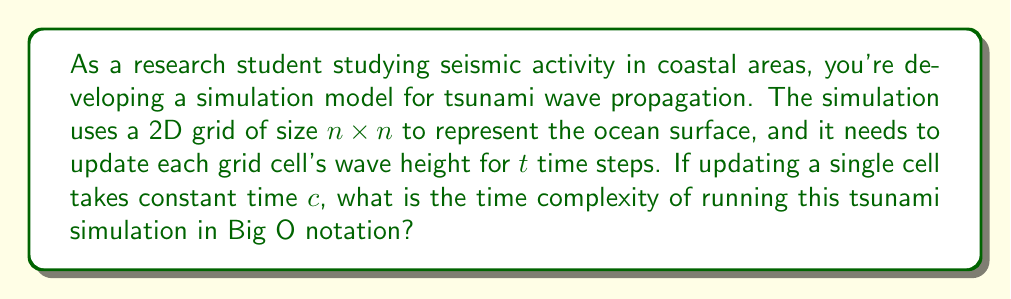Provide a solution to this math problem. To determine the time complexity of this tsunami simulation, let's break down the problem:

1. Grid size: The ocean surface is represented by an $n \times n$ grid, so there are $n^2$ total cells.

2. Time steps: The simulation runs for $t$ time steps.

3. Cell update time: Updating a single cell takes constant time $c$.

To run the simulation:

1. For each time step (total of $t$ steps):
   - We need to update every cell in the $n \times n$ grid.
   - There are $n^2$ cells to update.
   - Each cell update takes constant time $c$.

2. The total number of cell updates:
   $$ \text{Total updates} = t \times n^2 $$

3. The total time for all updates:
   $$ \text{Total time} = c \times t \times n^2 $$

4. In Big O notation, we drop constant factors and focus on the growth rate with respect to the input size. Here, both $n$ and $t$ can be considered input parameters that affect the runtime.

5. Therefore, the time complexity is:
   $$ O(tn^2) $$

This complexity indicates that the runtime grows linearly with the number of time steps and quadratically with the grid size.
Answer: $O(tn^2)$ 